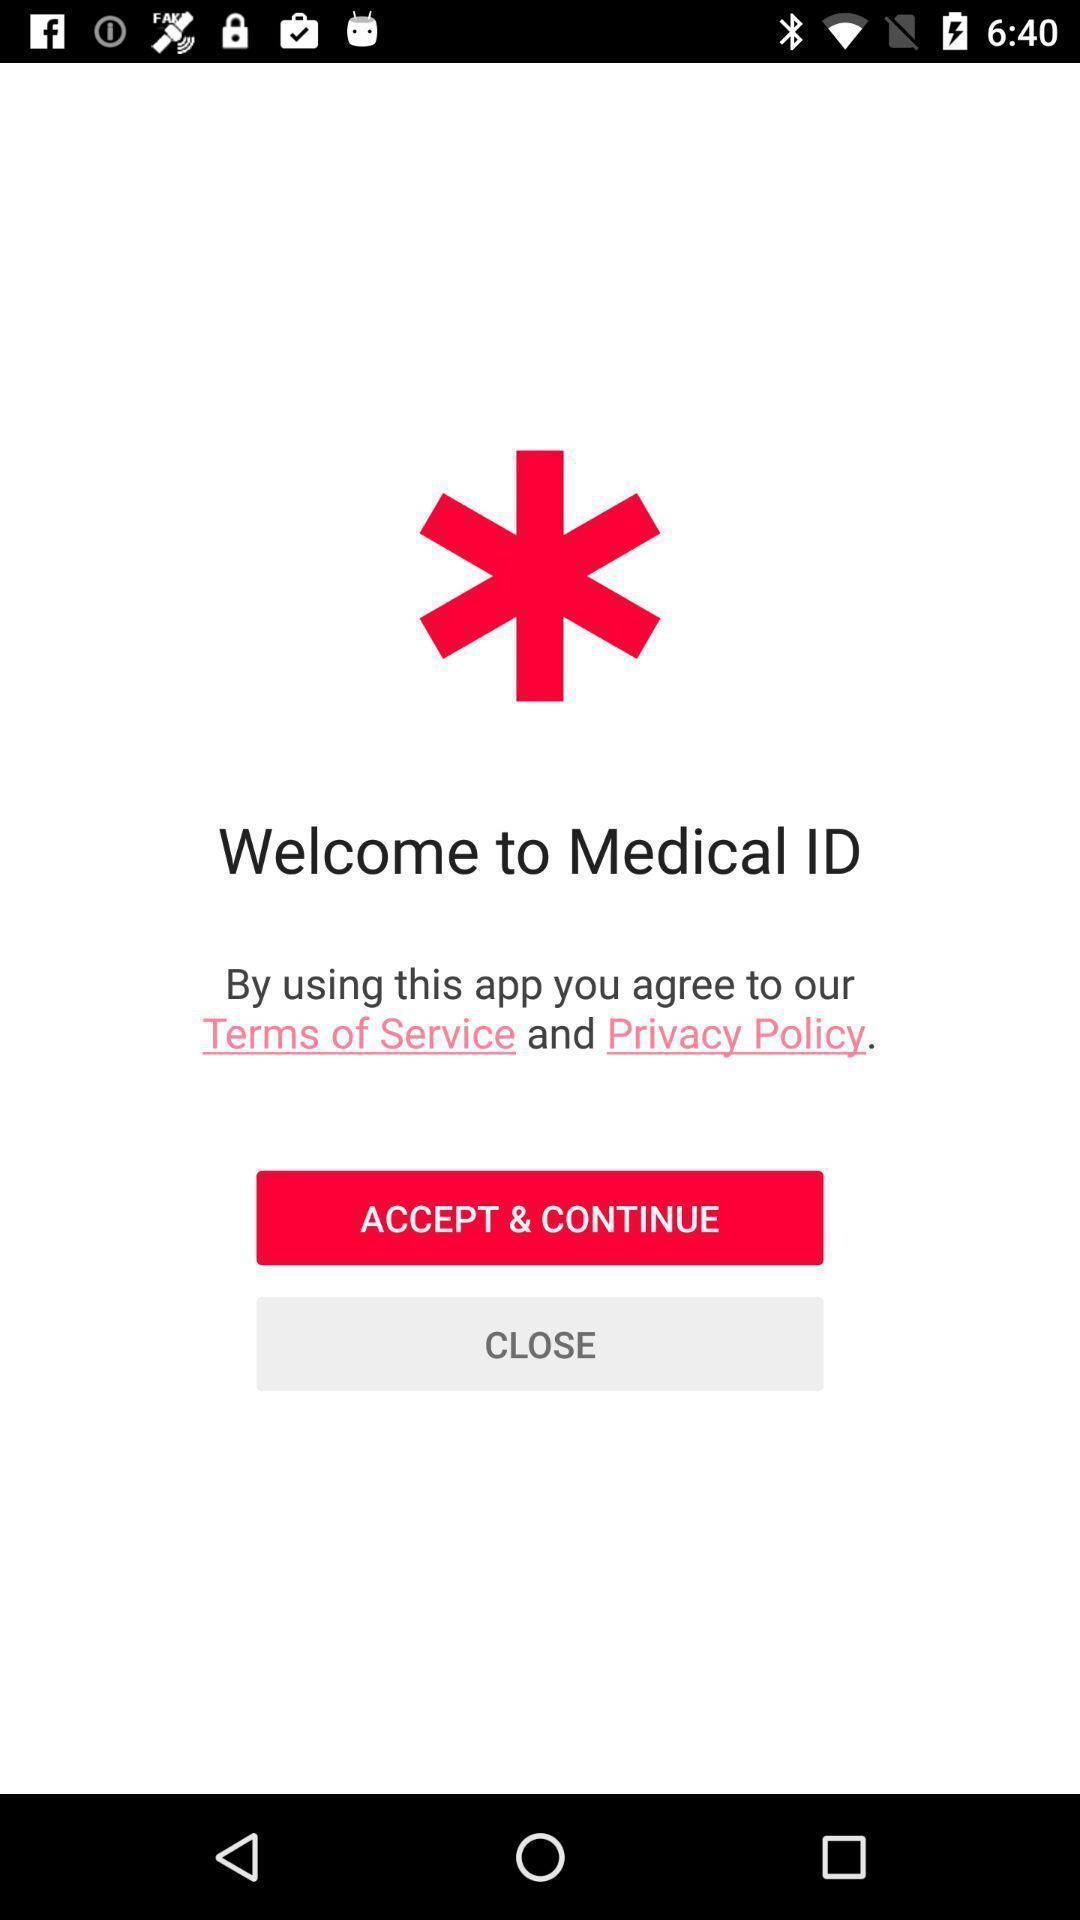Explain what's happening in this screen capture. Welcome page. 